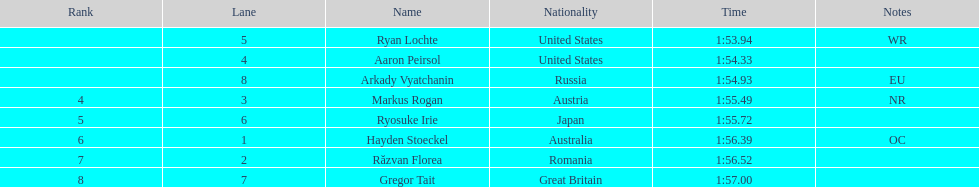Between austria and russia, who had a higher ranking? Russia. 